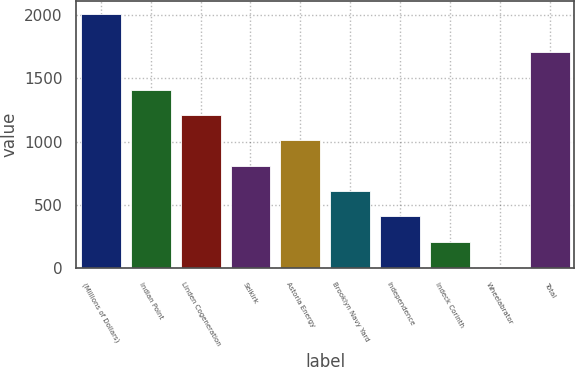Convert chart to OTSL. <chart><loc_0><loc_0><loc_500><loc_500><bar_chart><fcel>(Millions of Dollars)<fcel>Indian Point<fcel>Linden Cogeneration<fcel>Selkirk<fcel>Astoria Energy<fcel>Brooklyn Navy Yard<fcel>Independence<fcel>Indeck Corinth<fcel>Wheelabrator<fcel>Total<nl><fcel>2009<fcel>1409.3<fcel>1209.4<fcel>809.6<fcel>1009.5<fcel>609.7<fcel>409.8<fcel>209.9<fcel>10<fcel>1706<nl></chart> 